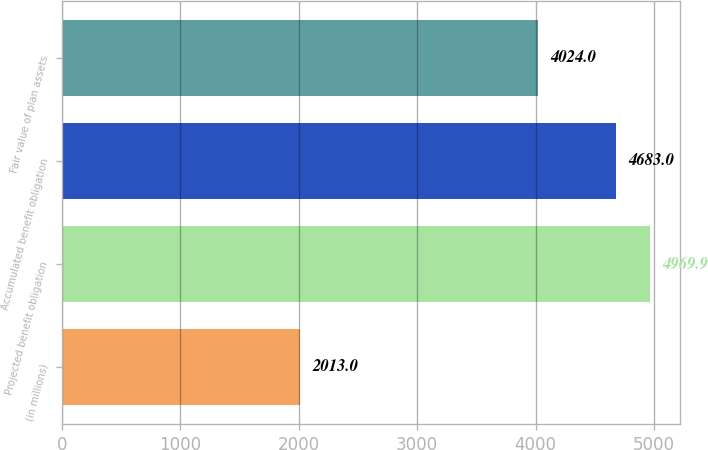Convert chart. <chart><loc_0><loc_0><loc_500><loc_500><bar_chart><fcel>(in millions)<fcel>Projected benefit obligation<fcel>Accumulated benefit obligation<fcel>Fair value of plan assets<nl><fcel>2013<fcel>4969.9<fcel>4683<fcel>4024<nl></chart> 